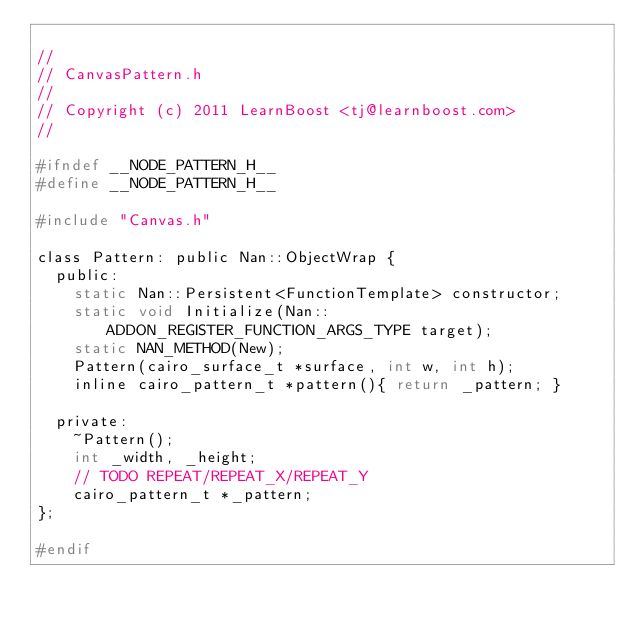<code> <loc_0><loc_0><loc_500><loc_500><_C_>
//
// CanvasPattern.h
//
// Copyright (c) 2011 LearnBoost <tj@learnboost.com>
//

#ifndef __NODE_PATTERN_H__
#define __NODE_PATTERN_H__

#include "Canvas.h"

class Pattern: public Nan::ObjectWrap {
  public:
    static Nan::Persistent<FunctionTemplate> constructor;
    static void Initialize(Nan::ADDON_REGISTER_FUNCTION_ARGS_TYPE target);
    static NAN_METHOD(New);
    Pattern(cairo_surface_t *surface, int w, int h);
    inline cairo_pattern_t *pattern(){ return _pattern; }

  private:
    ~Pattern();
    int _width, _height;
    // TODO REPEAT/REPEAT_X/REPEAT_Y
    cairo_pattern_t *_pattern;
};

#endif
</code> 